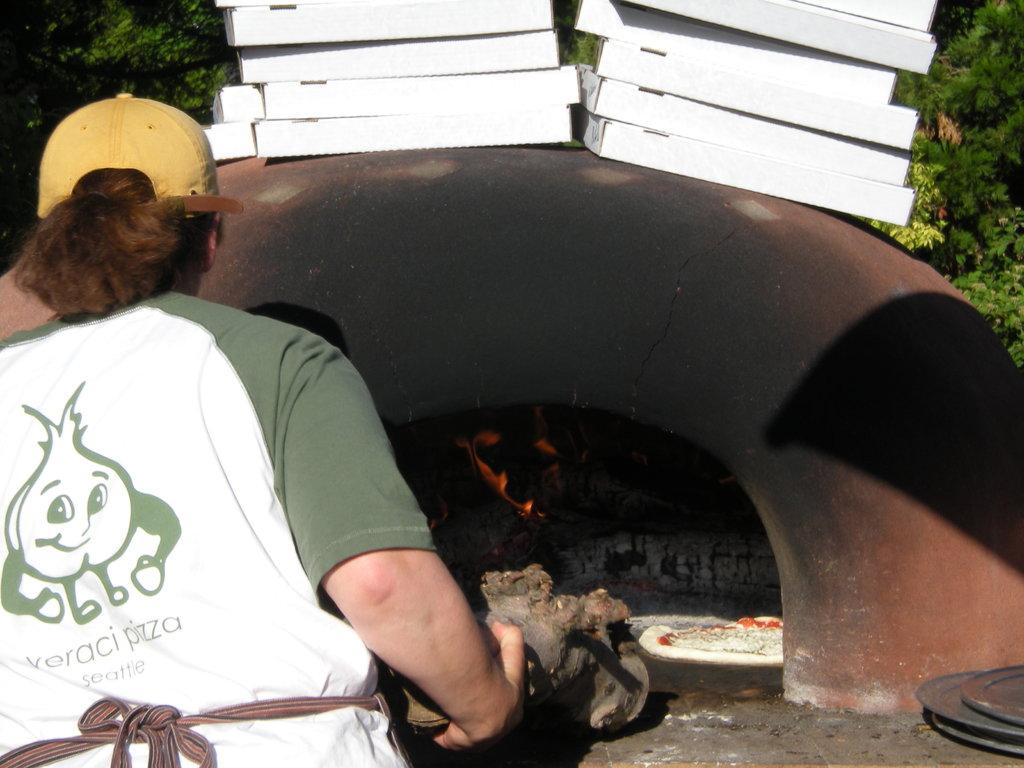What kind of food does the shirt mention?
Your answer should be very brief. Pizza. What pizza place is that?
Your answer should be compact. Veraci pizza. 